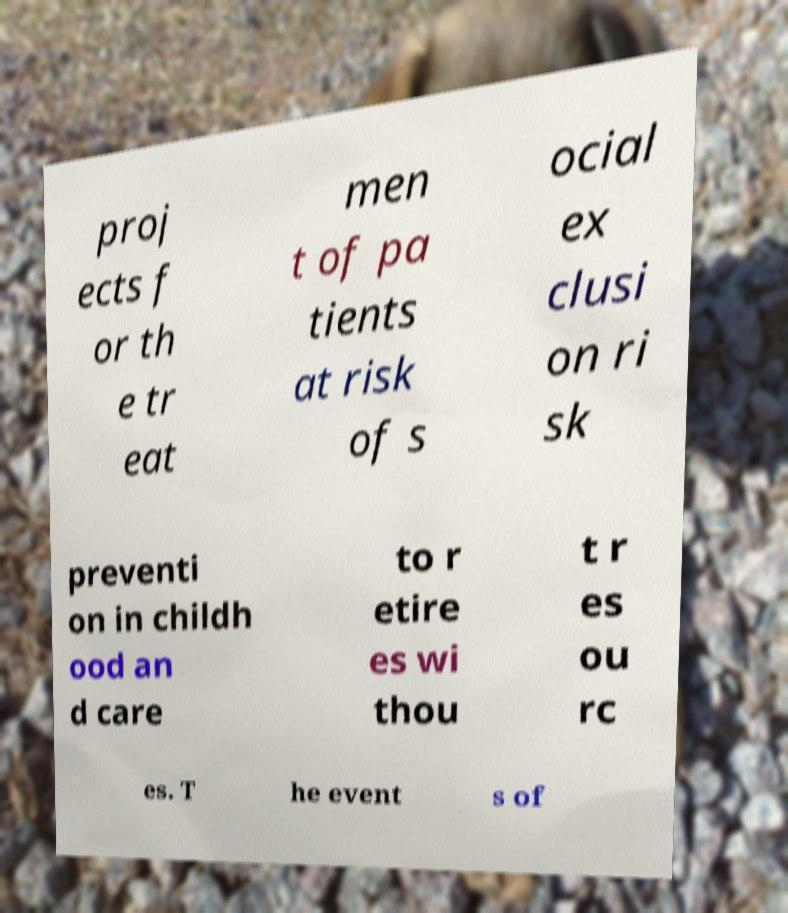Can you read and provide the text displayed in the image?This photo seems to have some interesting text. Can you extract and type it out for me? proj ects f or th e tr eat men t of pa tients at risk of s ocial ex clusi on ri sk preventi on in childh ood an d care to r etire es wi thou t r es ou rc es. T he event s of 